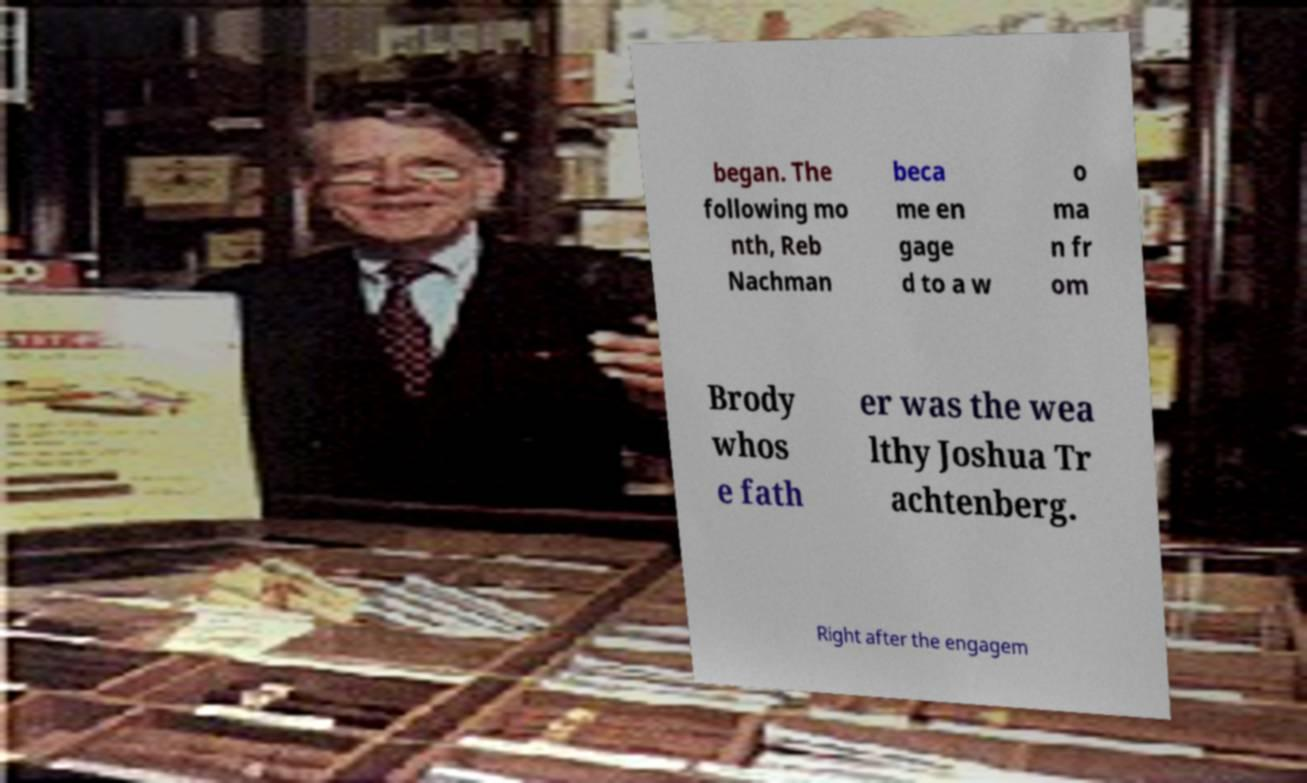Please read and relay the text visible in this image. What does it say? began. The following mo nth, Reb Nachman beca me en gage d to a w o ma n fr om Brody whos e fath er was the wea lthy Joshua Tr achtenberg. Right after the engagem 